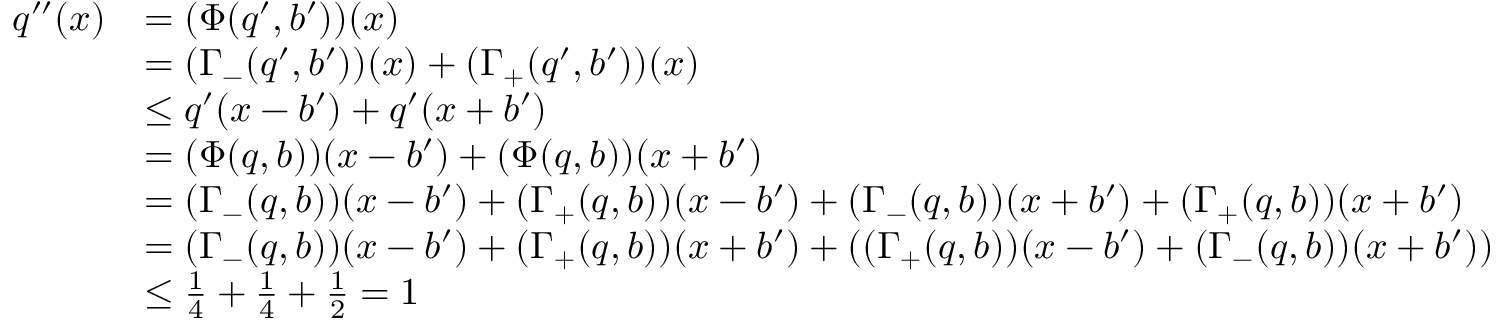<formula> <loc_0><loc_0><loc_500><loc_500>\begin{array} { r l } { q ^ { \prime \prime } ( x ) } & { = ( \Phi ( q ^ { \prime } , b ^ { \prime } ) ) ( x ) } \\ & { = ( \Gamma _ { - } ( q ^ { \prime } , b ^ { \prime } ) ) ( x ) + ( \Gamma _ { + } ( q ^ { \prime } , b ^ { \prime } ) ) ( x ) } \\ & { \leq q ^ { \prime } ( x - b ^ { \prime } ) + q ^ { \prime } ( x + b ^ { \prime } ) } \\ & { = ( \Phi ( q , b ) ) ( x - b ^ { \prime } ) + ( \Phi ( q , b ) ) ( x + b ^ { \prime } ) } \\ & { = ( \Gamma _ { - } ( q , b ) ) ( x - b ^ { \prime } ) + ( \Gamma _ { + } ( q , b ) ) ( x - b ^ { \prime } ) + ( \Gamma _ { - } ( q , b ) ) ( x + b ^ { \prime } ) + ( \Gamma _ { + } ( q , b ) ) ( x + b ^ { \prime } ) } \\ & { = ( \Gamma _ { - } ( q , b ) ) ( x - b ^ { \prime } ) + ( \Gamma _ { + } ( q , b ) ) ( x + b ^ { \prime } ) + ( ( \Gamma _ { + } ( q , b ) ) ( x - b ^ { \prime } ) + ( \Gamma _ { - } ( q , b ) ) ( x + b ^ { \prime } ) ) } \\ & { \leq \frac { 1 } { 4 } + \frac { 1 } { 4 } + \frac { 1 } { 2 } = 1 } \end{array}</formula> 